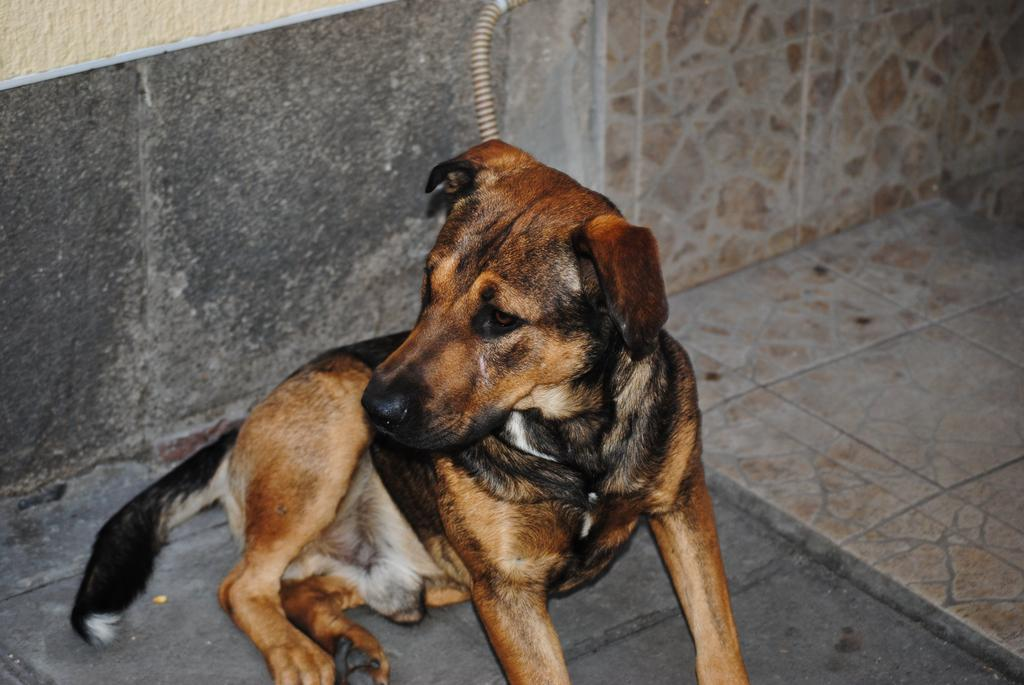What type of animal is in the image? There is a dog in the image. What color is the dog? The dog is brown in color. What is at the bottom of the image? There is a floor at the bottom of the image. What can be seen in the background of the image? There is a wall in the background of the image. What type of meal is the dog eating in the image? There is no meal present in the image; the dog is not shown eating anything. Can you tell me how high the dog is jumping in the image? There is no indication that the dog is jumping in the image; it is standing on the floor. 